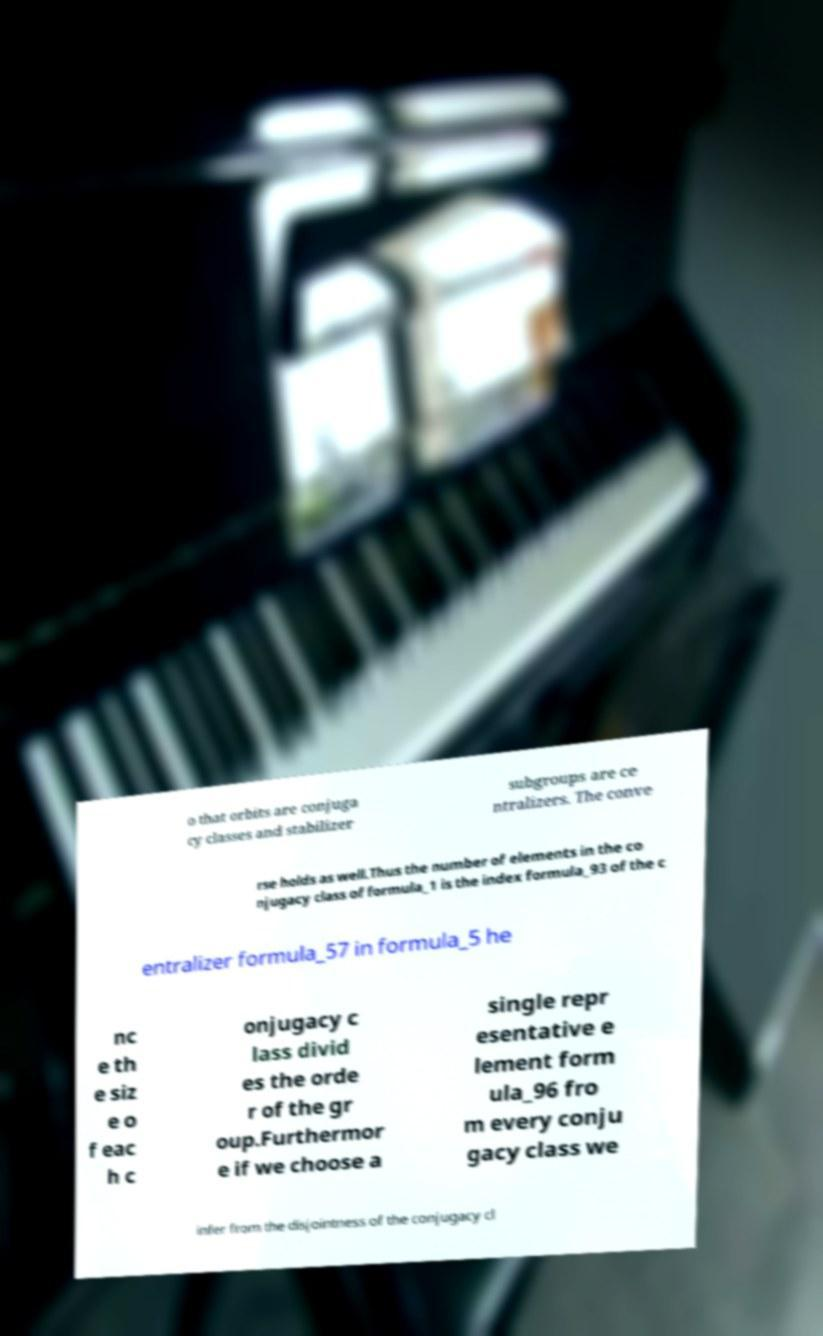Please read and relay the text visible in this image. What does it say? o that orbits are conjuga cy classes and stabilizer subgroups are ce ntralizers. The conve rse holds as well.Thus the number of elements in the co njugacy class of formula_1 is the index formula_93 of the c entralizer formula_57 in formula_5 he nc e th e siz e o f eac h c onjugacy c lass divid es the orde r of the gr oup.Furthermor e if we choose a single repr esentative e lement form ula_96 fro m every conju gacy class we infer from the disjointness of the conjugacy cl 